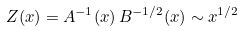Convert formula to latex. <formula><loc_0><loc_0><loc_500><loc_500>Z ( x ) = A ^ { - 1 } ( x ) \, B ^ { - 1 / 2 } ( x ) \sim x ^ { 1 / 2 }</formula> 